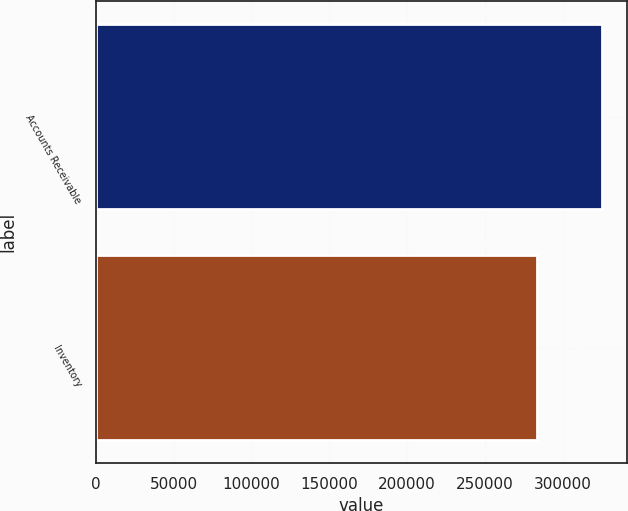Convert chart. <chart><loc_0><loc_0><loc_500><loc_500><bar_chart><fcel>Accounts Receivable<fcel>Inventory<nl><fcel>325144<fcel>283337<nl></chart> 